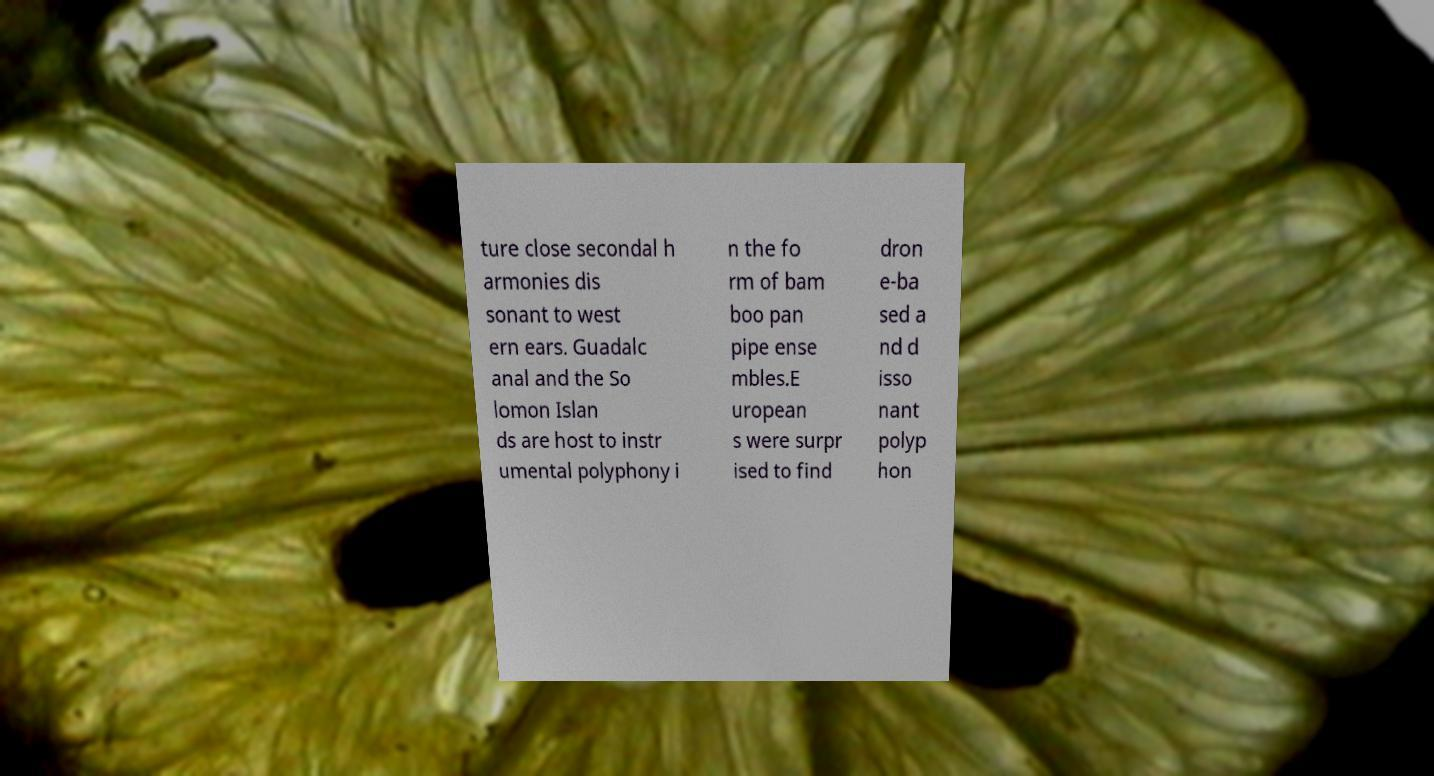I need the written content from this picture converted into text. Can you do that? ture close secondal h armonies dis sonant to west ern ears. Guadalc anal and the So lomon Islan ds are host to instr umental polyphony i n the fo rm of bam boo pan pipe ense mbles.E uropean s were surpr ised to find dron e-ba sed a nd d isso nant polyp hon 